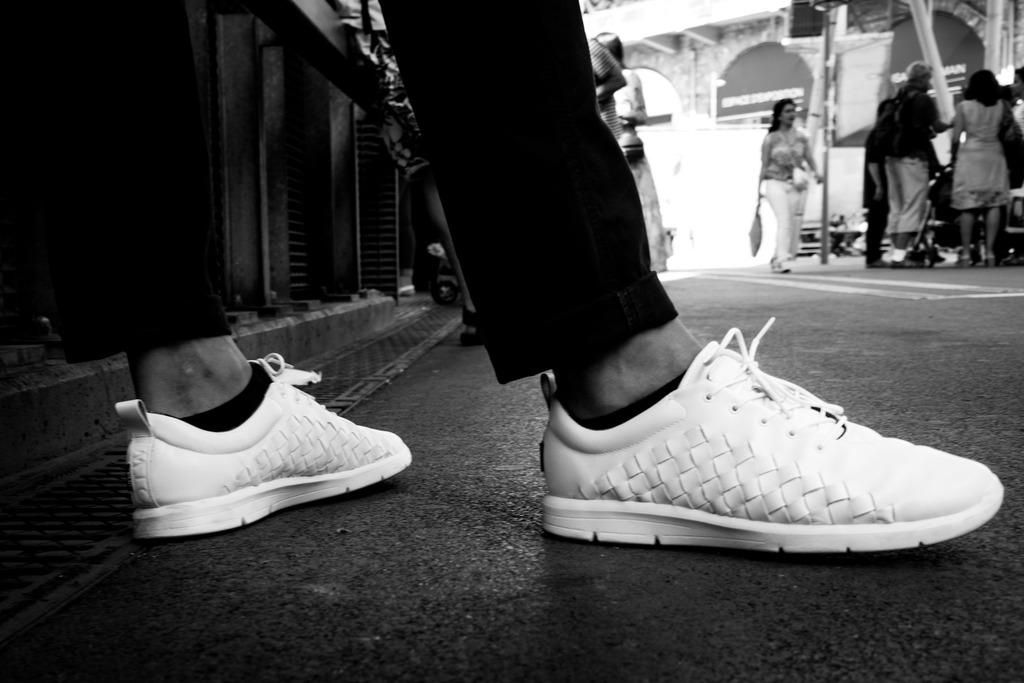What is the focus of the image? The image shows a close view of a person's legs. What type of shoes is the person wearing? The person is wearing white shoes. Can you describe the scene in the background? There is: There is a group of girls standing in the background. What might the girls be doing in the background? The girls appear to be discussing something. What type of bubble can be seen floating near the person's legs in the image? There is no bubble present in the image; it only shows a close view of a person's legs and a group of girls in the background. 